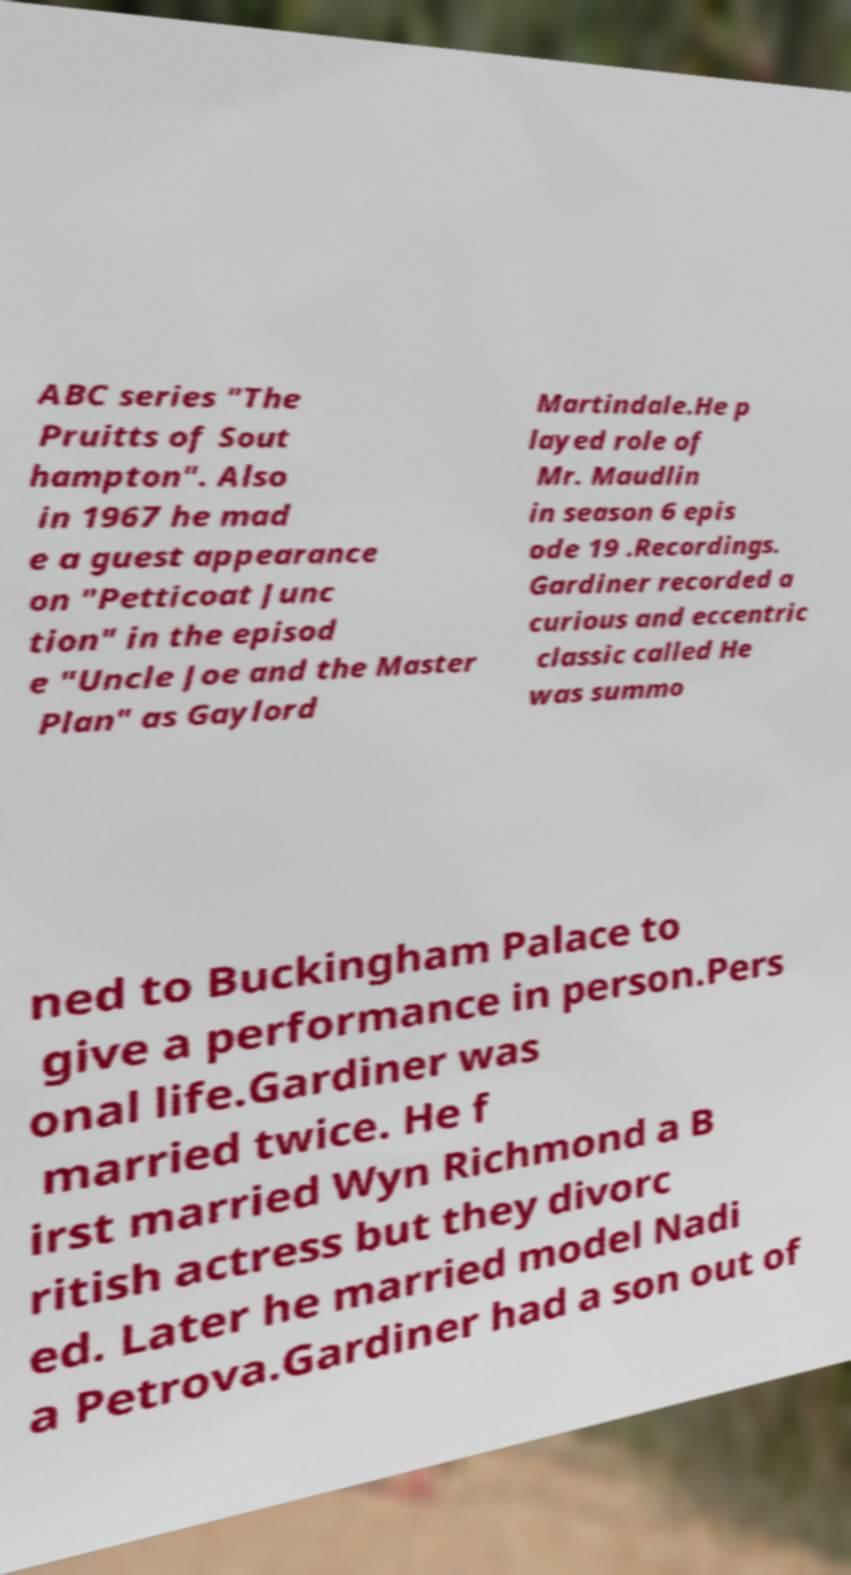I need the written content from this picture converted into text. Can you do that? ABC series "The Pruitts of Sout hampton". Also in 1967 he mad e a guest appearance on "Petticoat Junc tion" in the episod e "Uncle Joe and the Master Plan" as Gaylord Martindale.He p layed role of Mr. Maudlin in season 6 epis ode 19 .Recordings. Gardiner recorded a curious and eccentric classic called He was summo ned to Buckingham Palace to give a performance in person.Pers onal life.Gardiner was married twice. He f irst married Wyn Richmond a B ritish actress but they divorc ed. Later he married model Nadi a Petrova.Gardiner had a son out of 